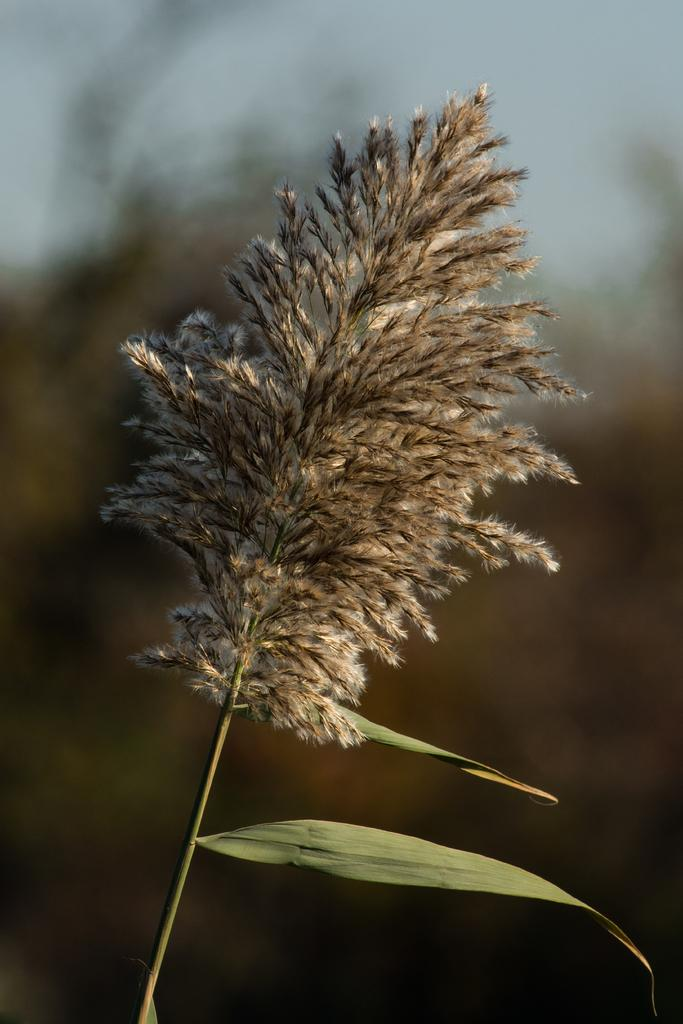What is present in the image? There is a plant in the image. Can you describe the background of the image? The background of the image is blurred. What type of meat is being cooked in the image? There is no meat or any cooking activity present in the image. How many bags of popcorn can be seen in the image? There are no bags of popcorn present in the image. 